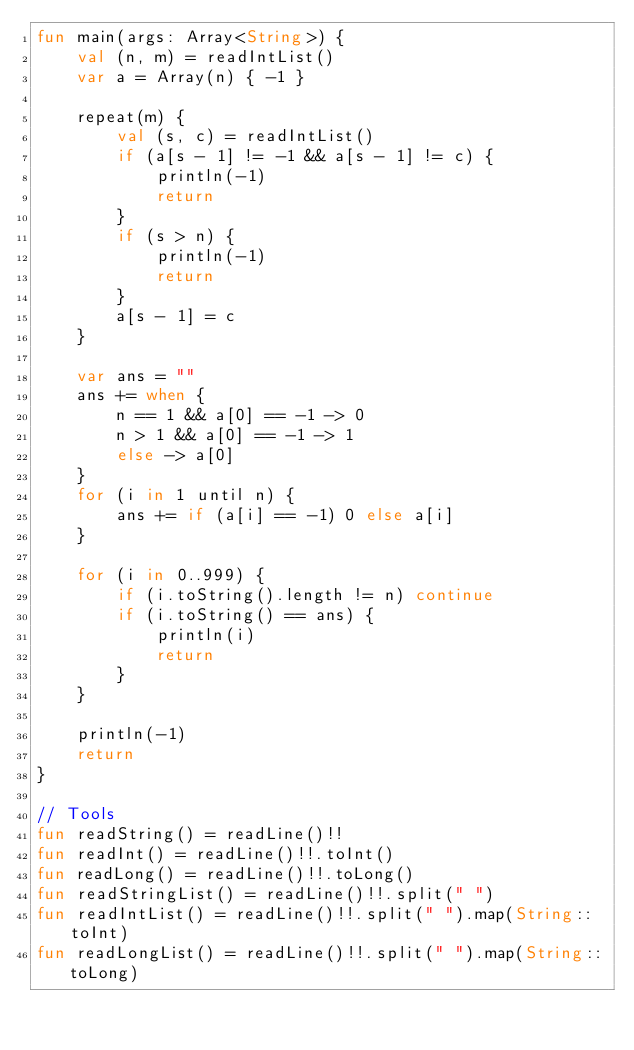Convert code to text. <code><loc_0><loc_0><loc_500><loc_500><_Kotlin_>fun main(args: Array<String>) {
    val (n, m) = readIntList()
    var a = Array(n) { -1 }

    repeat(m) {
        val (s, c) = readIntList()
        if (a[s - 1] != -1 && a[s - 1] != c) {
            println(-1)
            return
        }
        if (s > n) {
            println(-1)
            return
        }
        a[s - 1] = c
    }

    var ans = ""
    ans += when {
        n == 1 && a[0] == -1 -> 0
        n > 1 && a[0] == -1 -> 1
        else -> a[0]
    }
    for (i in 1 until n) {
        ans += if (a[i] == -1) 0 else a[i]
    }

    for (i in 0..999) {
        if (i.toString().length != n) continue
        if (i.toString() == ans) {
            println(i)
            return
        }
    }

    println(-1)
    return
}

// Tools
fun readString() = readLine()!!
fun readInt() = readLine()!!.toInt()
fun readLong() = readLine()!!.toLong()
fun readStringList() = readLine()!!.split(" ")
fun readIntList() = readLine()!!.split(" ").map(String::toInt)
fun readLongList() = readLine()!!.split(" ").map(String::toLong)</code> 